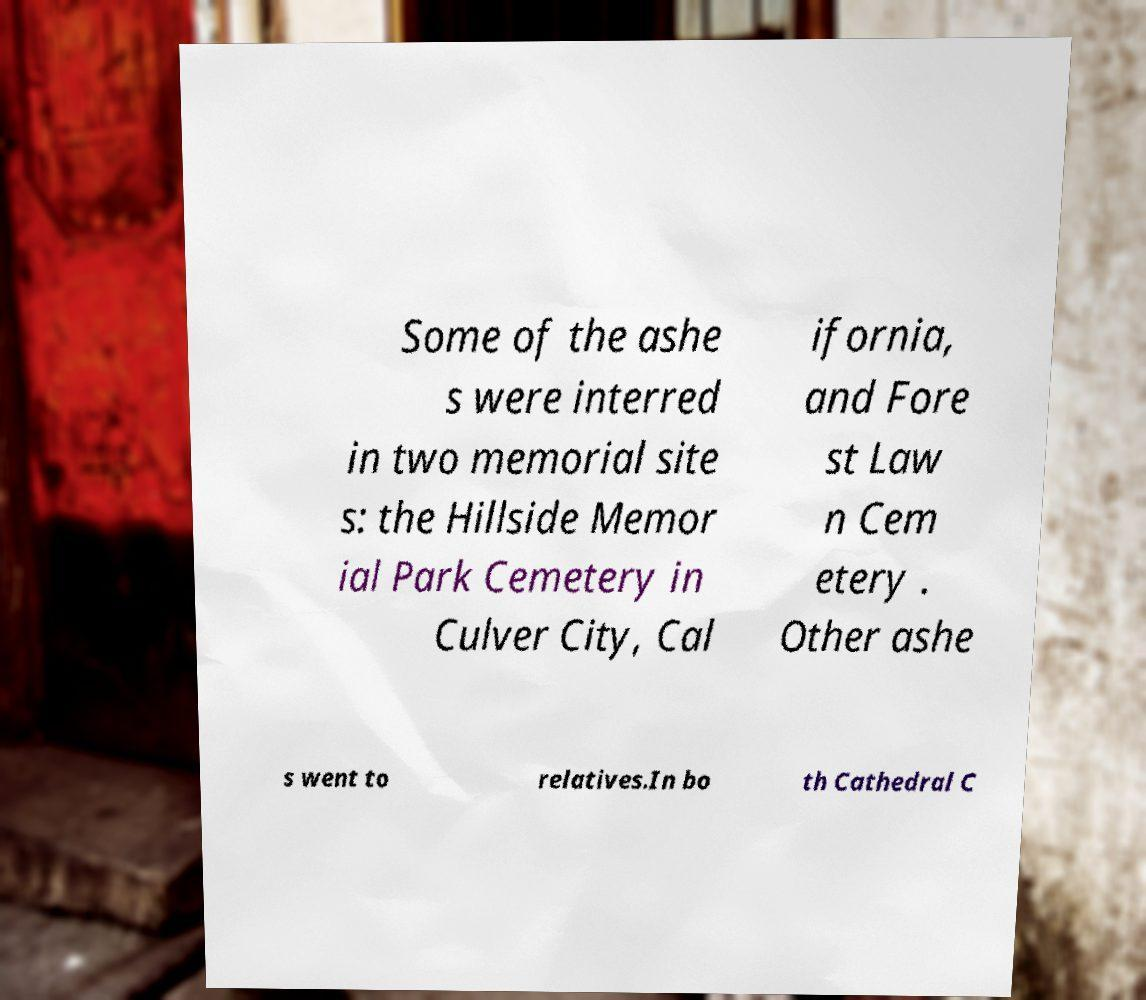Could you extract and type out the text from this image? Some of the ashe s were interred in two memorial site s: the Hillside Memor ial Park Cemetery in Culver City, Cal ifornia, and Fore st Law n Cem etery . Other ashe s went to relatives.In bo th Cathedral C 